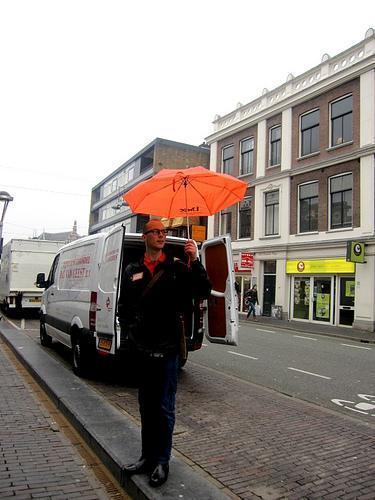How many umbrellas are there?
Give a very brief answer. 1. How many people are standing under the blue umbrella?
Give a very brief answer. 0. 